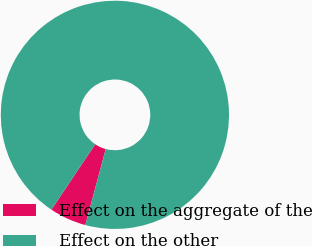<chart> <loc_0><loc_0><loc_500><loc_500><pie_chart><fcel>Effect on the aggregate of the<fcel>Effect on the other<nl><fcel>5.22%<fcel>94.78%<nl></chart> 